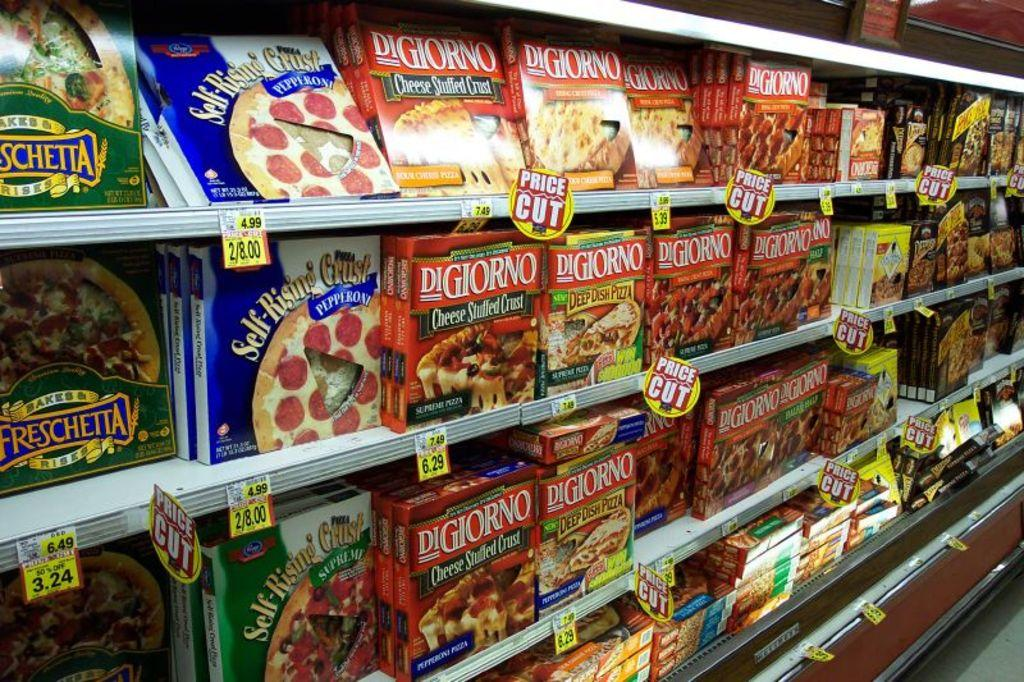<image>
Describe the image concisely. Rows of DiGiorno pizza placed in a supermarket for sale. 